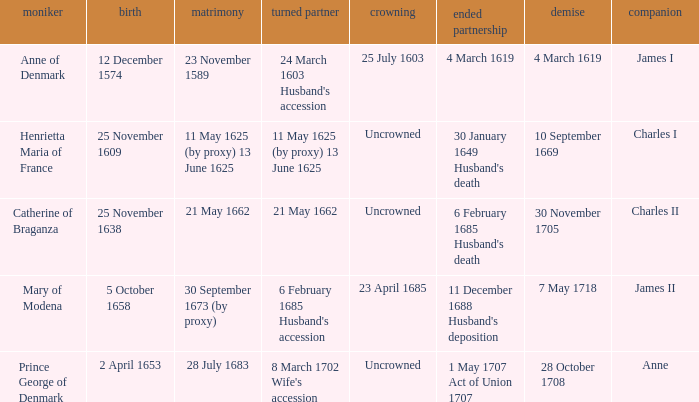When was the date of death for the person married to Charles II? 30 November 1705. 